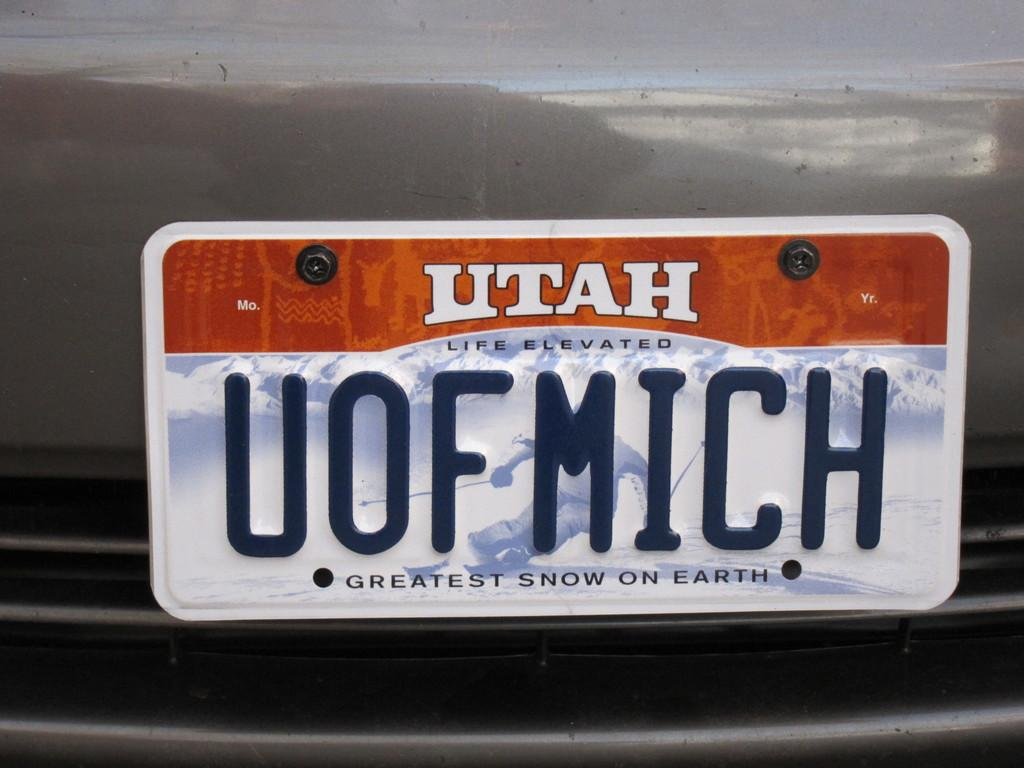<image>
Present a compact description of the photo's key features. A grey vehicle says Utah on the license plate. 